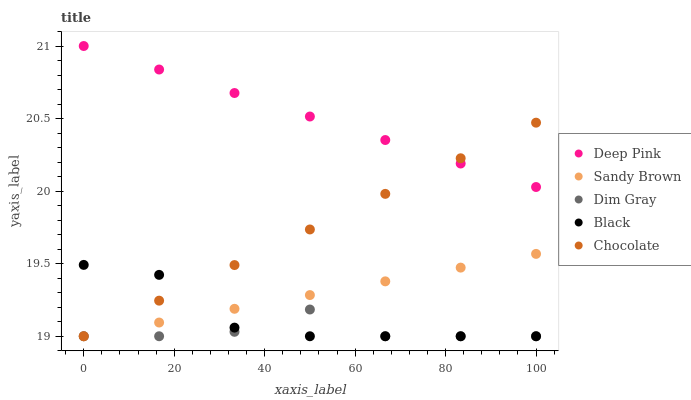Does Dim Gray have the minimum area under the curve?
Answer yes or no. Yes. Does Deep Pink have the maximum area under the curve?
Answer yes or no. Yes. Does Deep Pink have the minimum area under the curve?
Answer yes or no. No. Does Dim Gray have the maximum area under the curve?
Answer yes or no. No. Is Sandy Brown the smoothest?
Answer yes or no. Yes. Is Dim Gray the roughest?
Answer yes or no. Yes. Is Deep Pink the smoothest?
Answer yes or no. No. Is Deep Pink the roughest?
Answer yes or no. No. Does Black have the lowest value?
Answer yes or no. Yes. Does Deep Pink have the lowest value?
Answer yes or no. No. Does Deep Pink have the highest value?
Answer yes or no. Yes. Does Dim Gray have the highest value?
Answer yes or no. No. Is Dim Gray less than Deep Pink?
Answer yes or no. Yes. Is Deep Pink greater than Black?
Answer yes or no. Yes. Does Dim Gray intersect Chocolate?
Answer yes or no. Yes. Is Dim Gray less than Chocolate?
Answer yes or no. No. Is Dim Gray greater than Chocolate?
Answer yes or no. No. Does Dim Gray intersect Deep Pink?
Answer yes or no. No. 